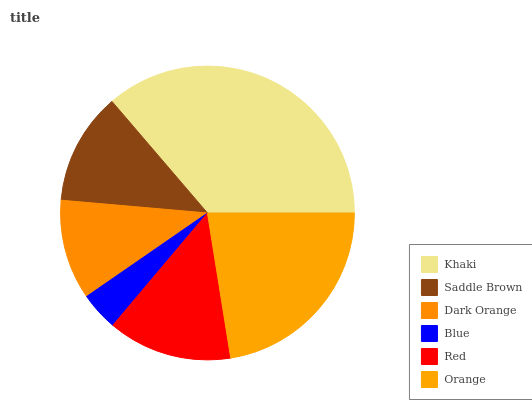Is Blue the minimum?
Answer yes or no. Yes. Is Khaki the maximum?
Answer yes or no. Yes. Is Saddle Brown the minimum?
Answer yes or no. No. Is Saddle Brown the maximum?
Answer yes or no. No. Is Khaki greater than Saddle Brown?
Answer yes or no. Yes. Is Saddle Brown less than Khaki?
Answer yes or no. Yes. Is Saddle Brown greater than Khaki?
Answer yes or no. No. Is Khaki less than Saddle Brown?
Answer yes or no. No. Is Red the high median?
Answer yes or no. Yes. Is Saddle Brown the low median?
Answer yes or no. Yes. Is Dark Orange the high median?
Answer yes or no. No. Is Blue the low median?
Answer yes or no. No. 